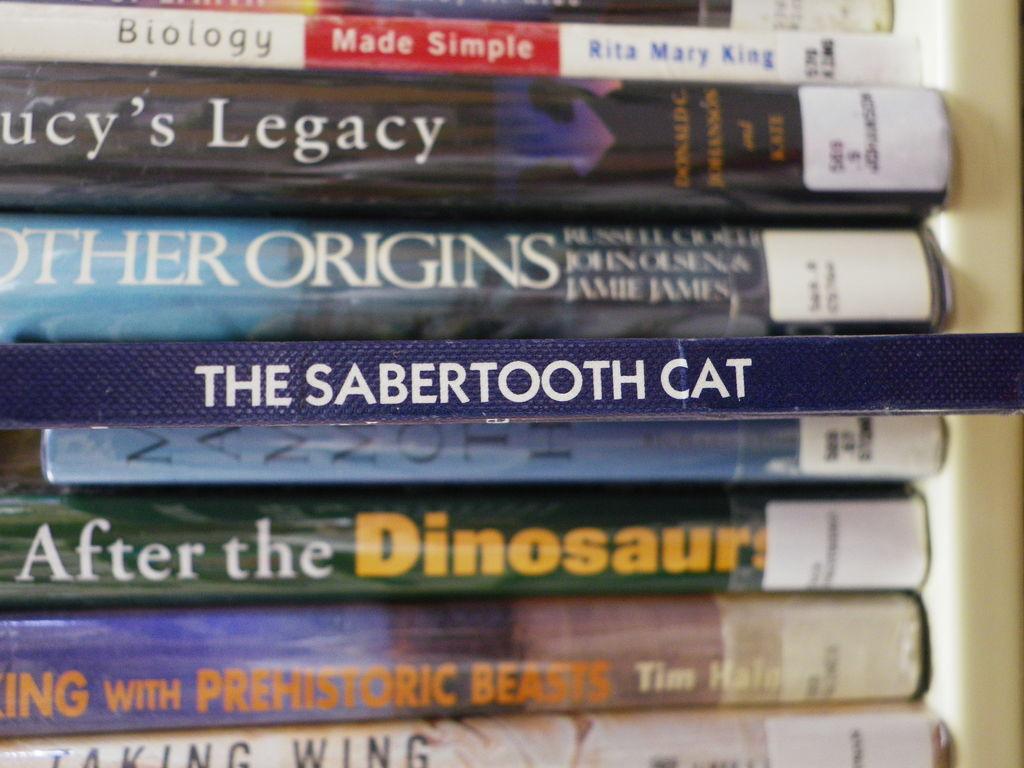What is the title of the blue book in the middle?
Your response must be concise. The sabertooth cat. 